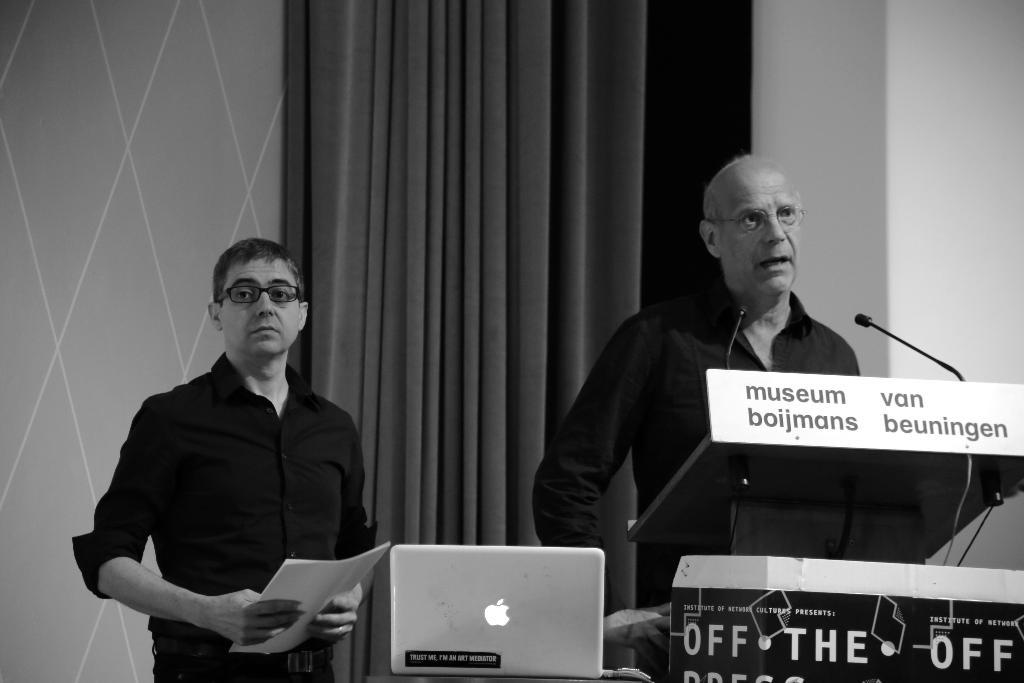How many people are present in the image? There are two persons standing in the image. What objects are in front of the persons? There are two microphones in front of the persons. What electronic device is visible in the image? A laptop is visible in the image. What can be seen in the background of the image? There is a curtain in the background of the image. What is the color scheme of the image? The image is in black and white. What type of boot is being worn by the person on the left in the image? There is no boot visible in the image, as the image is in black and white and does not show any footwear. What achievement has the person on the right in the image recently accomplished? There is no information about any achievements in the image, as it only shows two persons standing with microphones and a laptop. 